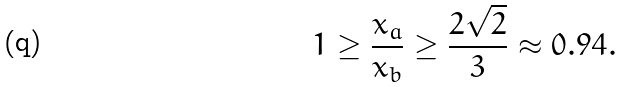Convert formula to latex. <formula><loc_0><loc_0><loc_500><loc_500>1 \geq { \frac { x _ { a } } { x _ { b } } } \geq { \frac { 2 { \sqrt { 2 } } } { 3 } } \approx 0 . 9 4 .</formula> 